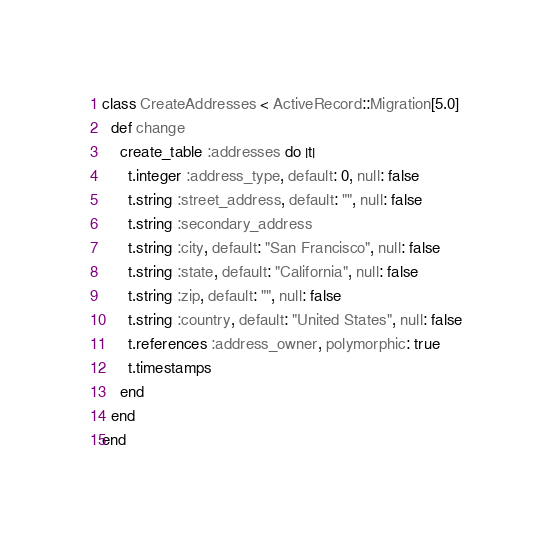<code> <loc_0><loc_0><loc_500><loc_500><_Ruby_>class CreateAddresses < ActiveRecord::Migration[5.0]
  def change
    create_table :addresses do |t|
      t.integer :address_type, default: 0, null: false
      t.string :street_address, default: "", null: false
      t.string :secondary_address
      t.string :city, default: "San Francisco", null: false
      t.string :state, default: "California", null: false
      t.string :zip, default: "", null: false
      t.string :country, default: "United States", null: false
      t.references :address_owner, polymorphic: true
      t.timestamps
    end
  end
end
</code> 